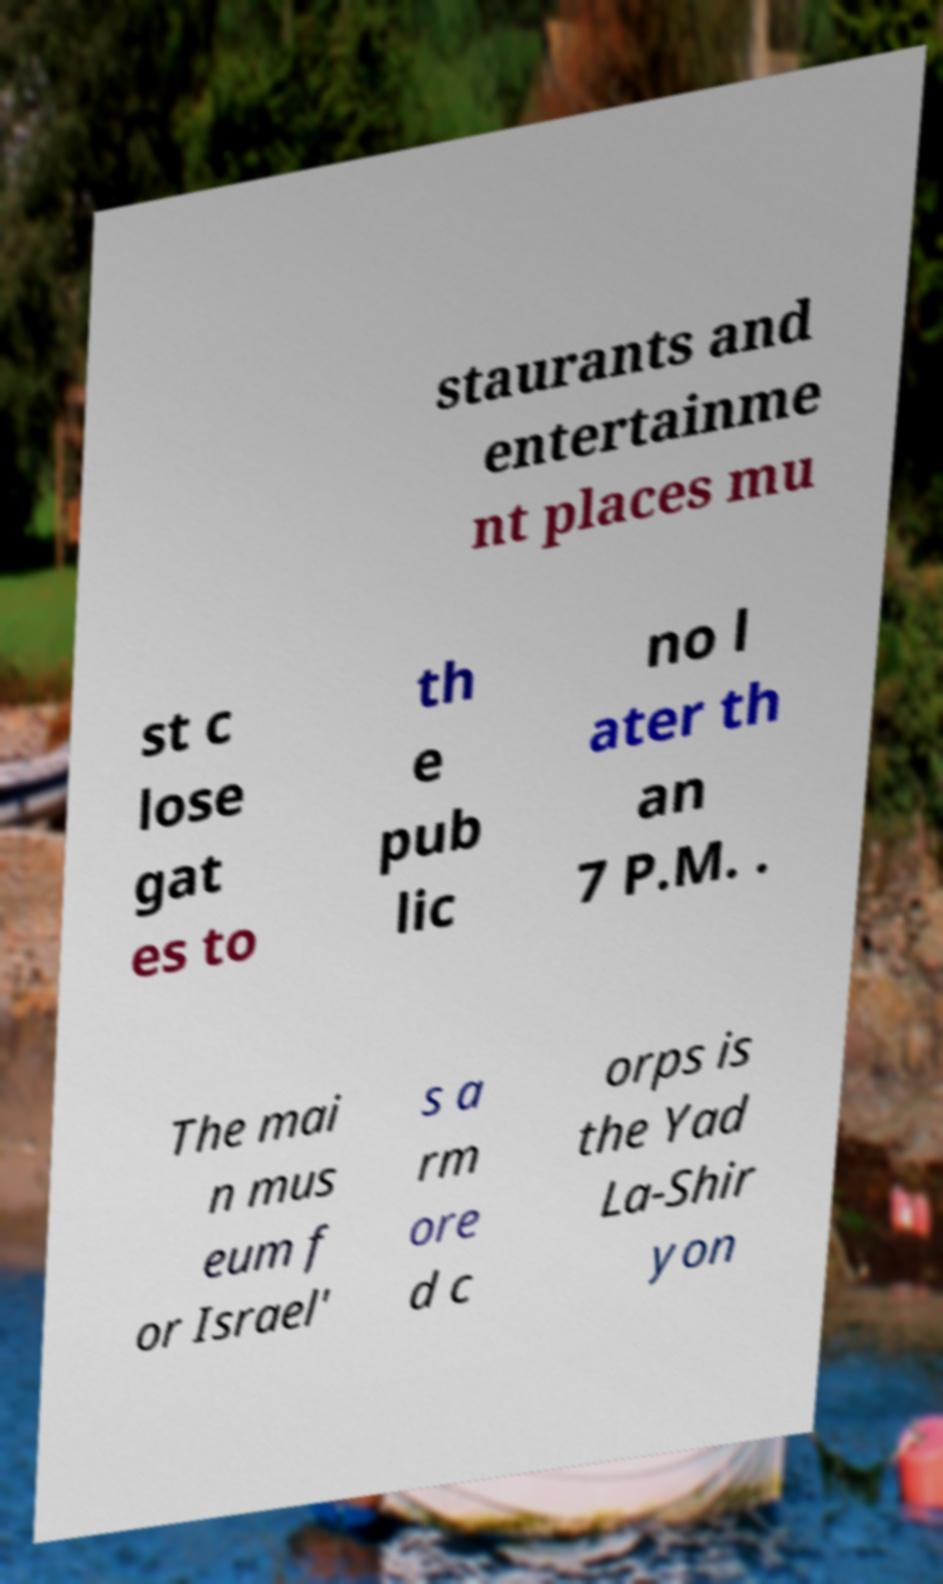Could you extract and type out the text from this image? staurants and entertainme nt places mu st c lose gat es to th e pub lic no l ater th an 7 P.M. . The mai n mus eum f or Israel' s a rm ore d c orps is the Yad La-Shir yon 